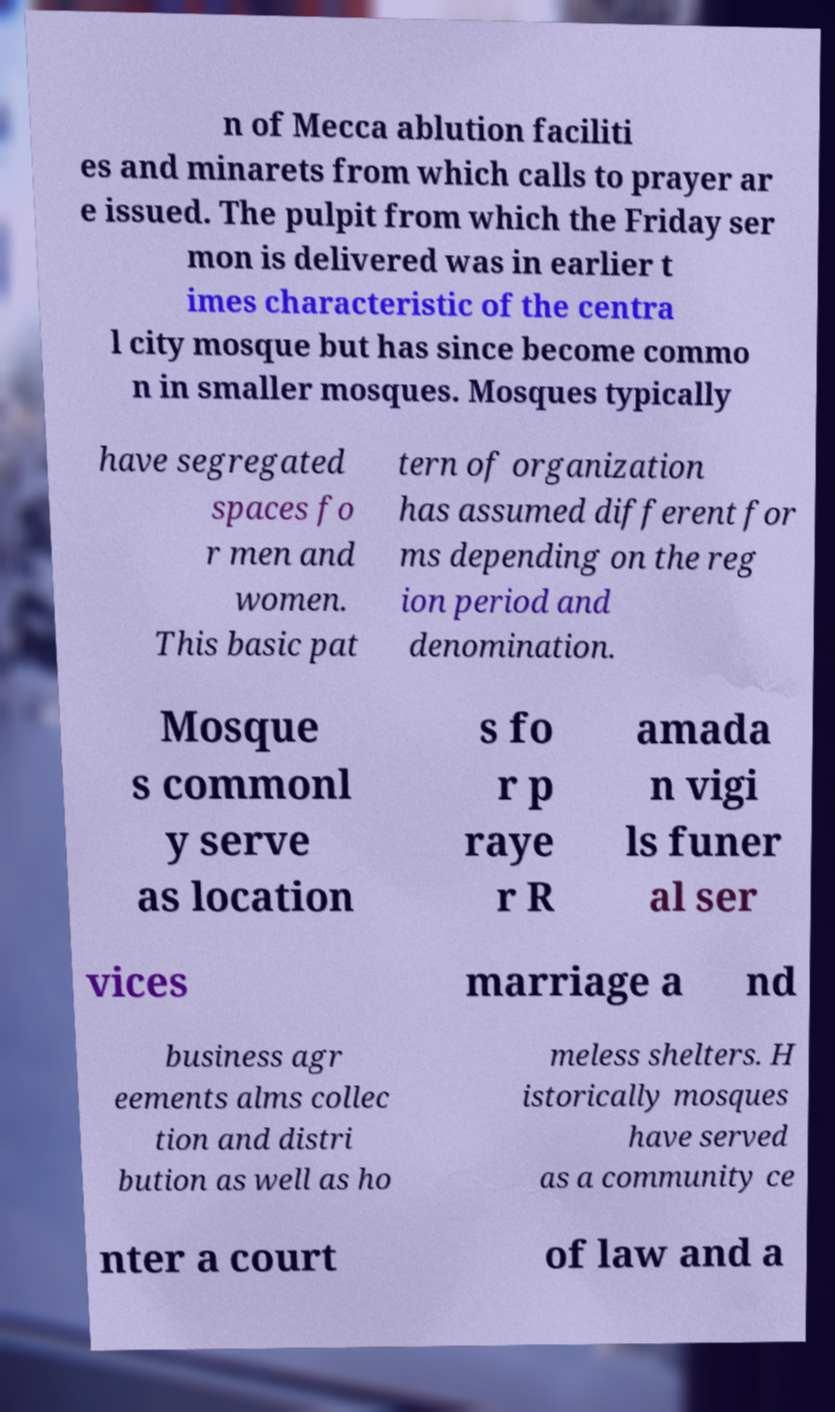Please identify and transcribe the text found in this image. n of Mecca ablution faciliti es and minarets from which calls to prayer ar e issued. The pulpit from which the Friday ser mon is delivered was in earlier t imes characteristic of the centra l city mosque but has since become commo n in smaller mosques. Mosques typically have segregated spaces fo r men and women. This basic pat tern of organization has assumed different for ms depending on the reg ion period and denomination. Mosque s commonl y serve as location s fo r p raye r R amada n vigi ls funer al ser vices marriage a nd business agr eements alms collec tion and distri bution as well as ho meless shelters. H istorically mosques have served as a community ce nter a court of law and a 